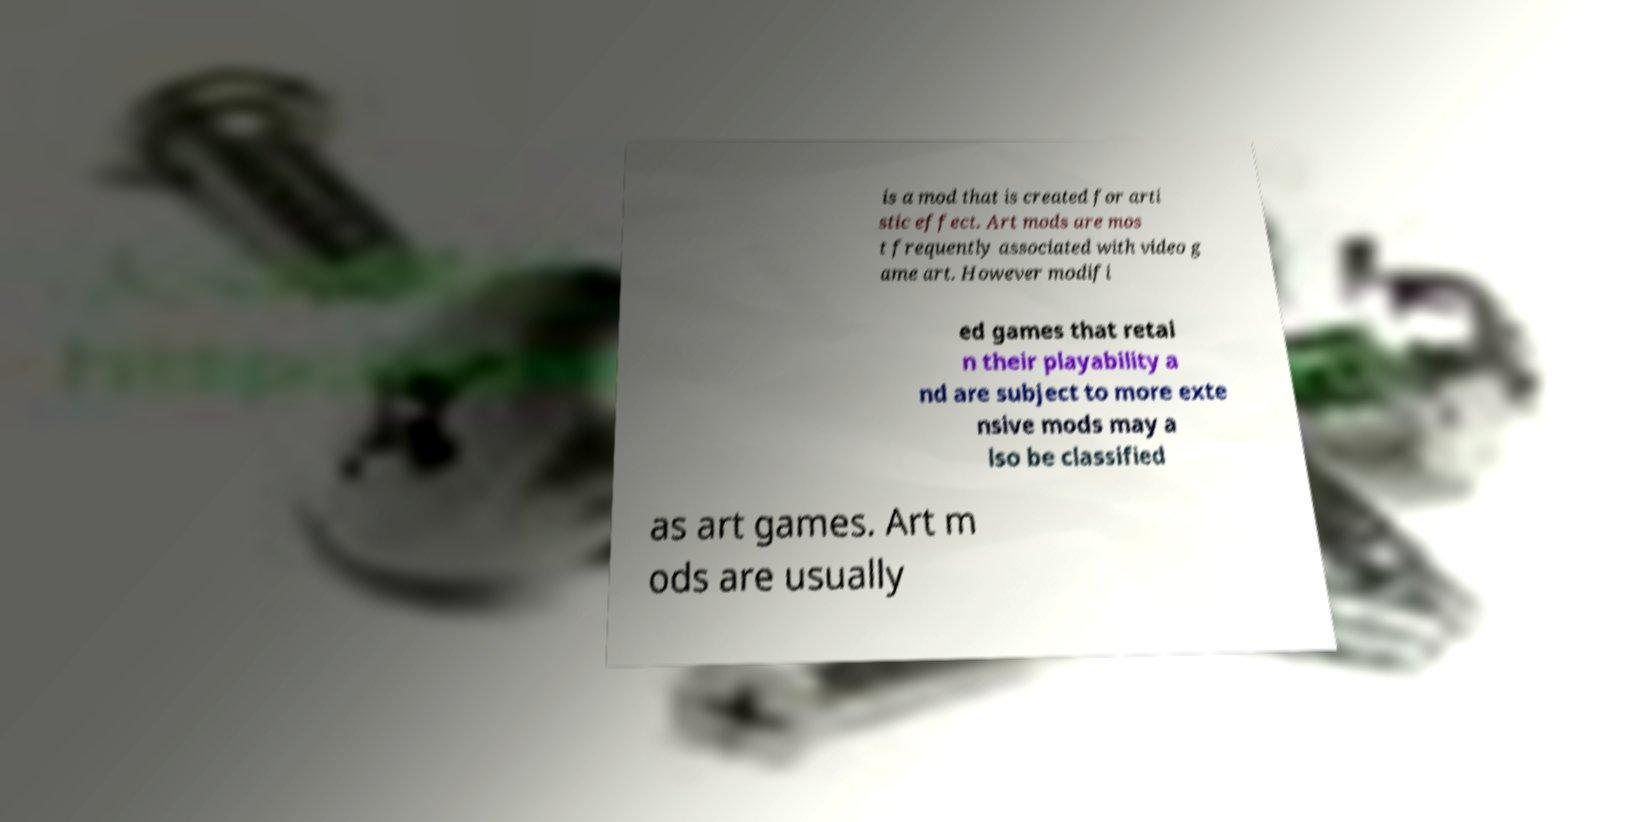What messages or text are displayed in this image? I need them in a readable, typed format. is a mod that is created for arti stic effect. Art mods are mos t frequently associated with video g ame art. However modifi ed games that retai n their playability a nd are subject to more exte nsive mods may a lso be classified as art games. Art m ods are usually 